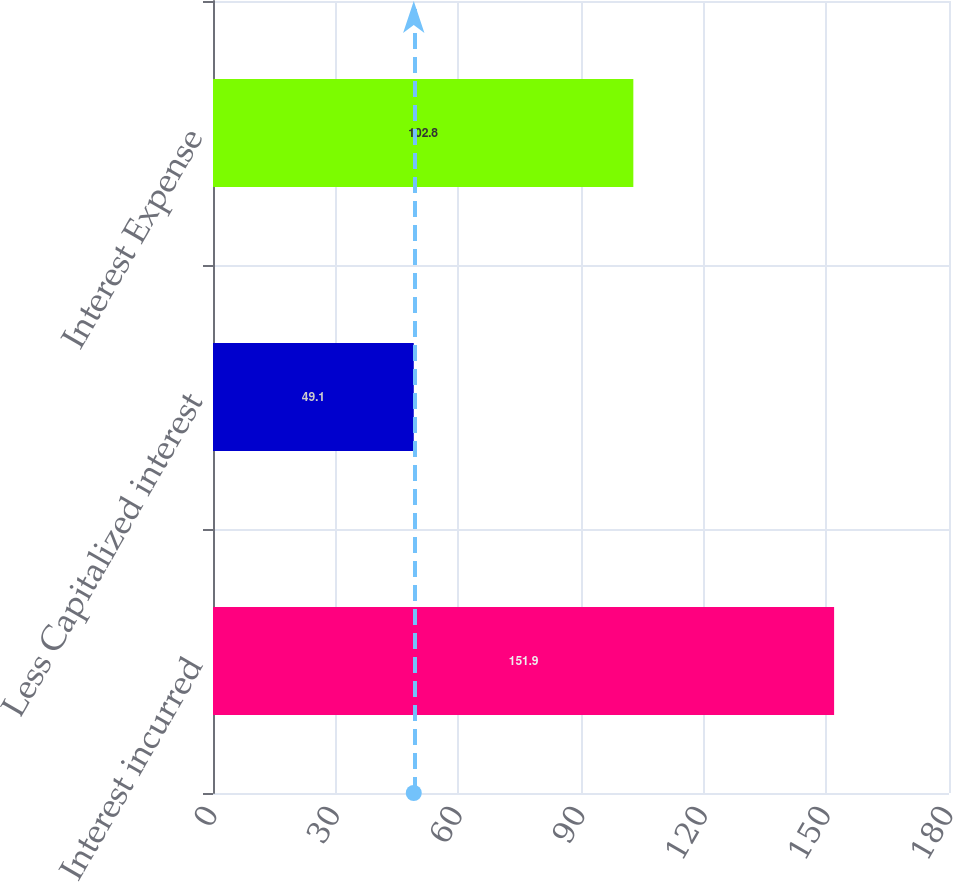Convert chart. <chart><loc_0><loc_0><loc_500><loc_500><bar_chart><fcel>Interest incurred<fcel>Less Capitalized interest<fcel>Interest Expense<nl><fcel>151.9<fcel>49.1<fcel>102.8<nl></chart> 